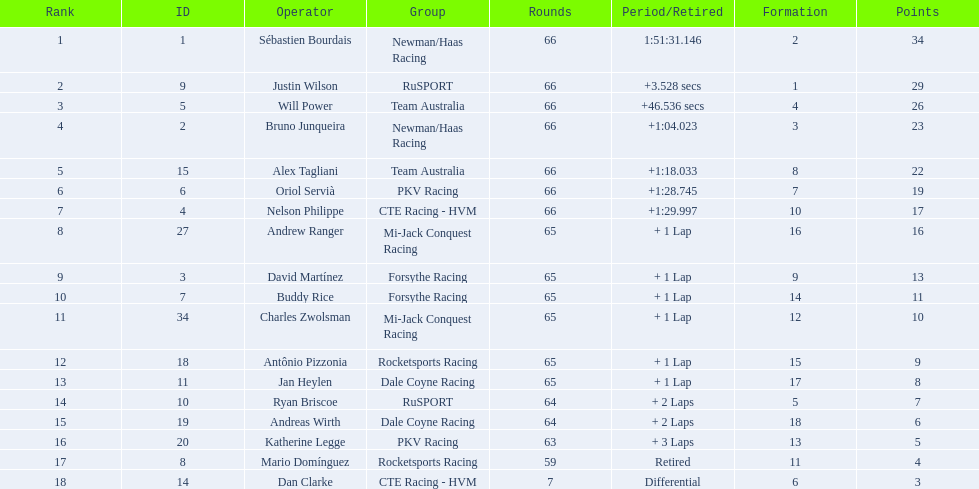What are the names of the drivers who were in position 14 through position 18? Ryan Briscoe, Andreas Wirth, Katherine Legge, Mario Domínguez, Dan Clarke. Of these , which ones didn't finish due to retired or differential? Mario Domínguez, Dan Clarke. Which one of the previous drivers retired? Mario Domínguez. Which of the drivers in question 2 had a differential? Dan Clarke. 